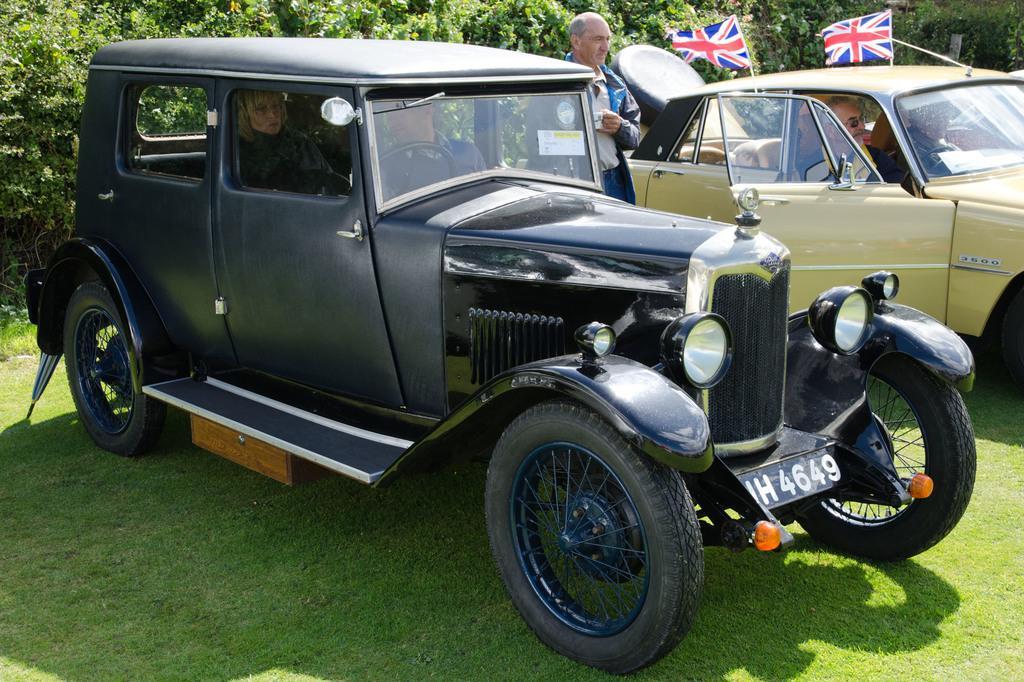In one or two sentences, can you explain what this image depicts? In this image I can see a car which is black in color on the ground and I can see few persons sitting in the car. I can see another car with few persons in it which is yellow in color and two flags on it. In the background I can see a person standing on the ground and few trees. 